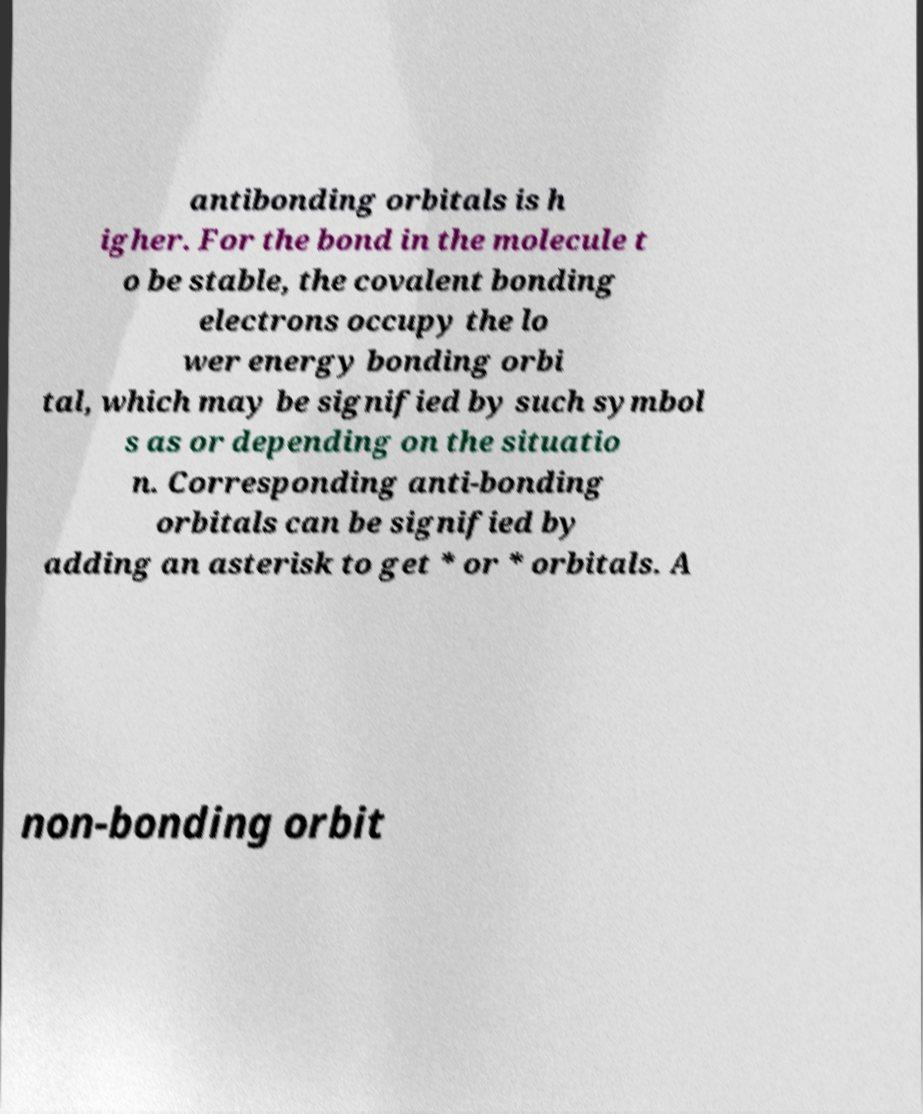Please identify and transcribe the text found in this image. antibonding orbitals is h igher. For the bond in the molecule t o be stable, the covalent bonding electrons occupy the lo wer energy bonding orbi tal, which may be signified by such symbol s as or depending on the situatio n. Corresponding anti-bonding orbitals can be signified by adding an asterisk to get * or * orbitals. A non-bonding orbit 